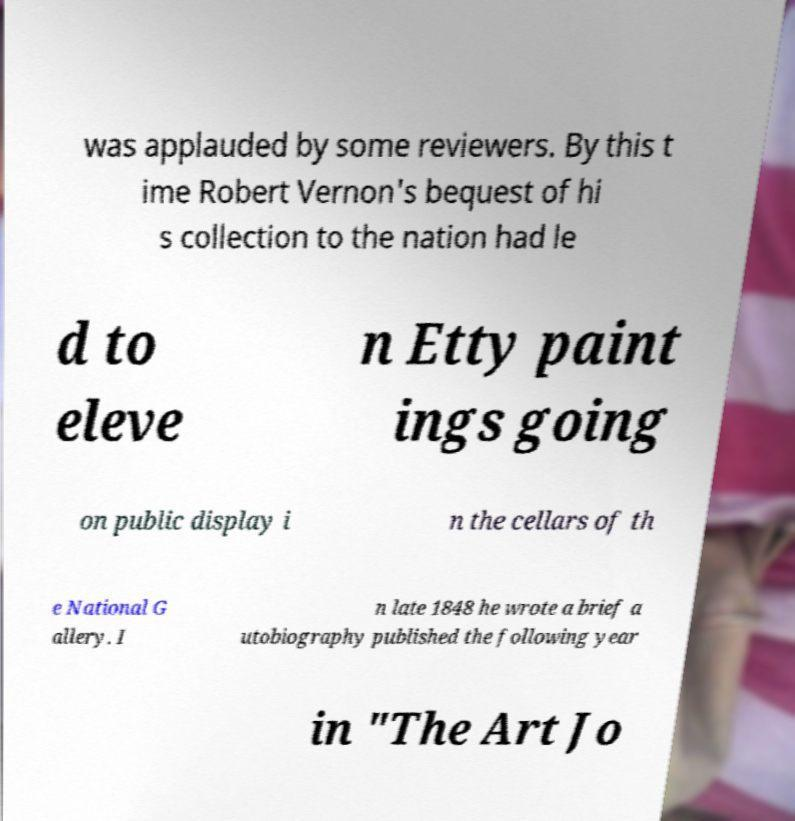Could you assist in decoding the text presented in this image and type it out clearly? was applauded by some reviewers. By this t ime Robert Vernon's bequest of hi s collection to the nation had le d to eleve n Etty paint ings going on public display i n the cellars of th e National G allery. I n late 1848 he wrote a brief a utobiography published the following year in "The Art Jo 